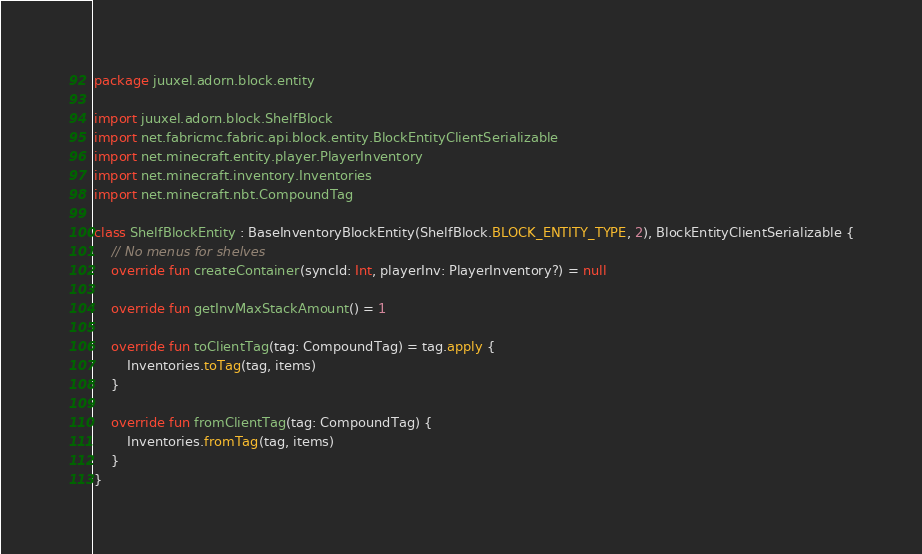Convert code to text. <code><loc_0><loc_0><loc_500><loc_500><_Kotlin_>package juuxel.adorn.block.entity

import juuxel.adorn.block.ShelfBlock
import net.fabricmc.fabric.api.block.entity.BlockEntityClientSerializable
import net.minecraft.entity.player.PlayerInventory
import net.minecraft.inventory.Inventories
import net.minecraft.nbt.CompoundTag

class ShelfBlockEntity : BaseInventoryBlockEntity(ShelfBlock.BLOCK_ENTITY_TYPE, 2), BlockEntityClientSerializable {
    // No menus for shelves
    override fun createContainer(syncId: Int, playerInv: PlayerInventory?) = null

    override fun getInvMaxStackAmount() = 1

    override fun toClientTag(tag: CompoundTag) = tag.apply {
        Inventories.toTag(tag, items)
    }

    override fun fromClientTag(tag: CompoundTag) {
        Inventories.fromTag(tag, items)
    }
}
</code> 